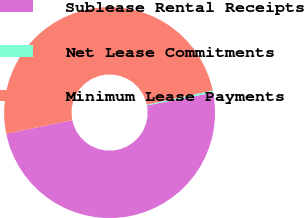Convert chart. <chart><loc_0><loc_0><loc_500><loc_500><pie_chart><fcel>Sublease Rental Receipts<fcel>Net Lease Commitments<fcel>Minimum Lease Payments<nl><fcel>49.81%<fcel>0.33%<fcel>49.86%<nl></chart> 